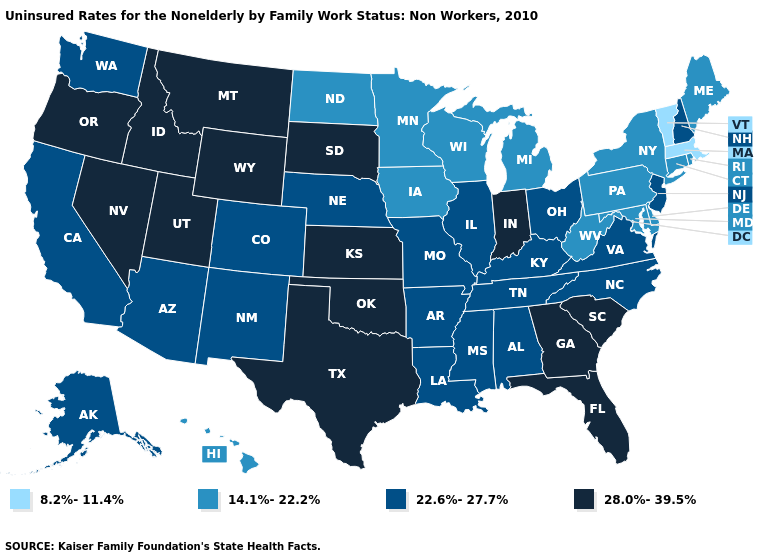Name the states that have a value in the range 8.2%-11.4%?
Write a very short answer. Massachusetts, Vermont. Name the states that have a value in the range 8.2%-11.4%?
Write a very short answer. Massachusetts, Vermont. Does Illinois have the same value as South Carolina?
Keep it brief. No. Name the states that have a value in the range 14.1%-22.2%?
Write a very short answer. Connecticut, Delaware, Hawaii, Iowa, Maine, Maryland, Michigan, Minnesota, New York, North Dakota, Pennsylvania, Rhode Island, West Virginia, Wisconsin. Which states have the highest value in the USA?
Give a very brief answer. Florida, Georgia, Idaho, Indiana, Kansas, Montana, Nevada, Oklahoma, Oregon, South Carolina, South Dakota, Texas, Utah, Wyoming. Does Pennsylvania have the highest value in the Northeast?
Keep it brief. No. Which states hav the highest value in the West?
Write a very short answer. Idaho, Montana, Nevada, Oregon, Utah, Wyoming. Among the states that border Idaho , does Washington have the highest value?
Short answer required. No. Which states have the lowest value in the MidWest?
Write a very short answer. Iowa, Michigan, Minnesota, North Dakota, Wisconsin. What is the value of Washington?
Short answer required. 22.6%-27.7%. Among the states that border New Jersey , which have the highest value?
Keep it brief. Delaware, New York, Pennsylvania. Name the states that have a value in the range 14.1%-22.2%?
Write a very short answer. Connecticut, Delaware, Hawaii, Iowa, Maine, Maryland, Michigan, Minnesota, New York, North Dakota, Pennsylvania, Rhode Island, West Virginia, Wisconsin. What is the value of Alabama?
Quick response, please. 22.6%-27.7%. What is the value of North Dakota?
Quick response, please. 14.1%-22.2%. Does Vermont have the lowest value in the USA?
Be succinct. Yes. 